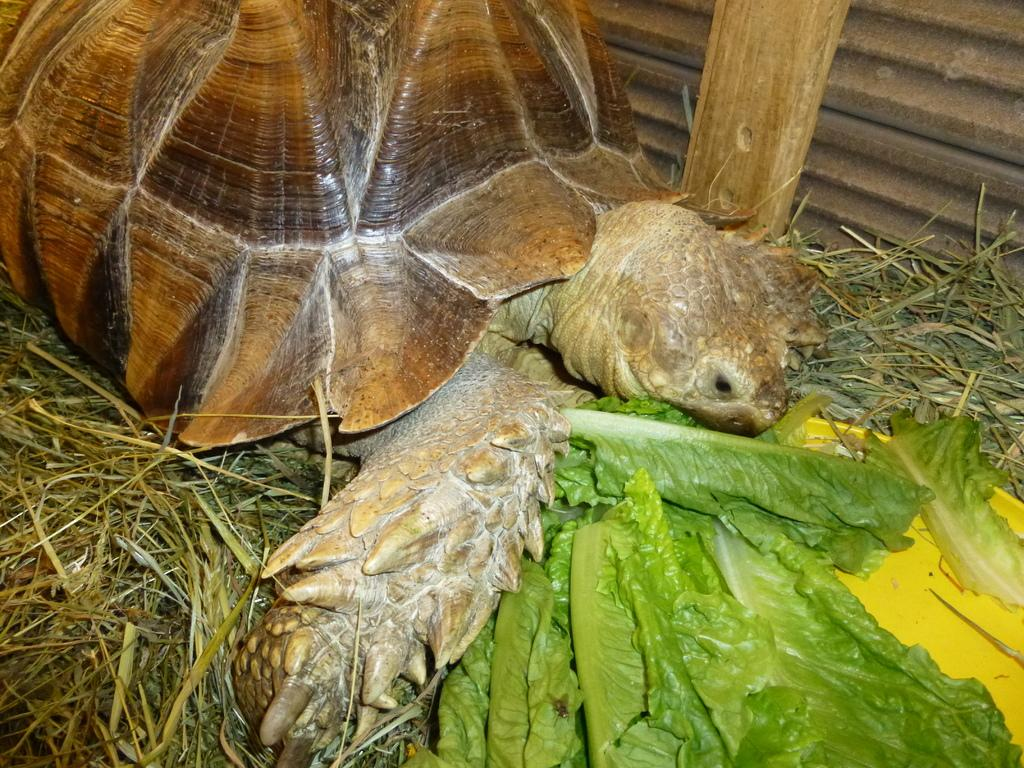What animal is in the image? There is a tortoise in the image. Where is the tortoise located? The tortoise is on the grass. What is placed beside the tortoise? There are green leaves in a plate beside the tortoise. What can be seen on the right side of the image? There is a wall on the right side of the image. How does the tortoise join the other animals in the image? There are no other animals present in the image, so the tortoise is not joining any other animals. What type of growth can be seen on the tortoise in the image? There is no visible growth on the tortoise in the image. 